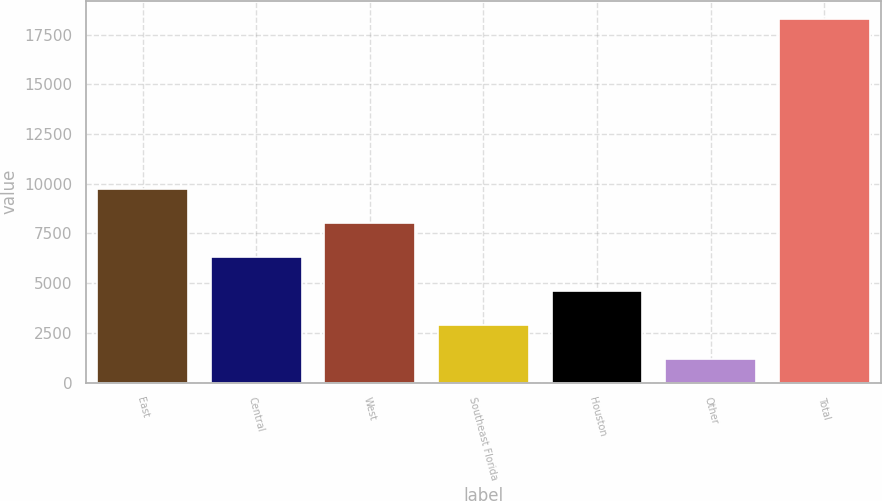<chart> <loc_0><loc_0><loc_500><loc_500><bar_chart><fcel>East<fcel>Central<fcel>West<fcel>Southeast Florida<fcel>Houston<fcel>Other<fcel>Total<nl><fcel>9747.5<fcel>6330.5<fcel>8039<fcel>2913.5<fcel>4622<fcel>1205<fcel>18290<nl></chart> 